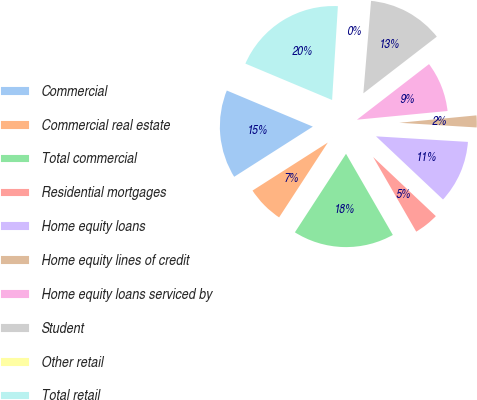<chart> <loc_0><loc_0><loc_500><loc_500><pie_chart><fcel>Commercial<fcel>Commercial real estate<fcel>Total commercial<fcel>Residential mortgages<fcel>Home equity loans<fcel>Home equity lines of credit<fcel>Home equity loans serviced by<fcel>Student<fcel>Other retail<fcel>Total retail<nl><fcel>15.36%<fcel>6.78%<fcel>17.51%<fcel>4.64%<fcel>11.07%<fcel>2.49%<fcel>8.93%<fcel>13.22%<fcel>0.34%<fcel>19.66%<nl></chart> 